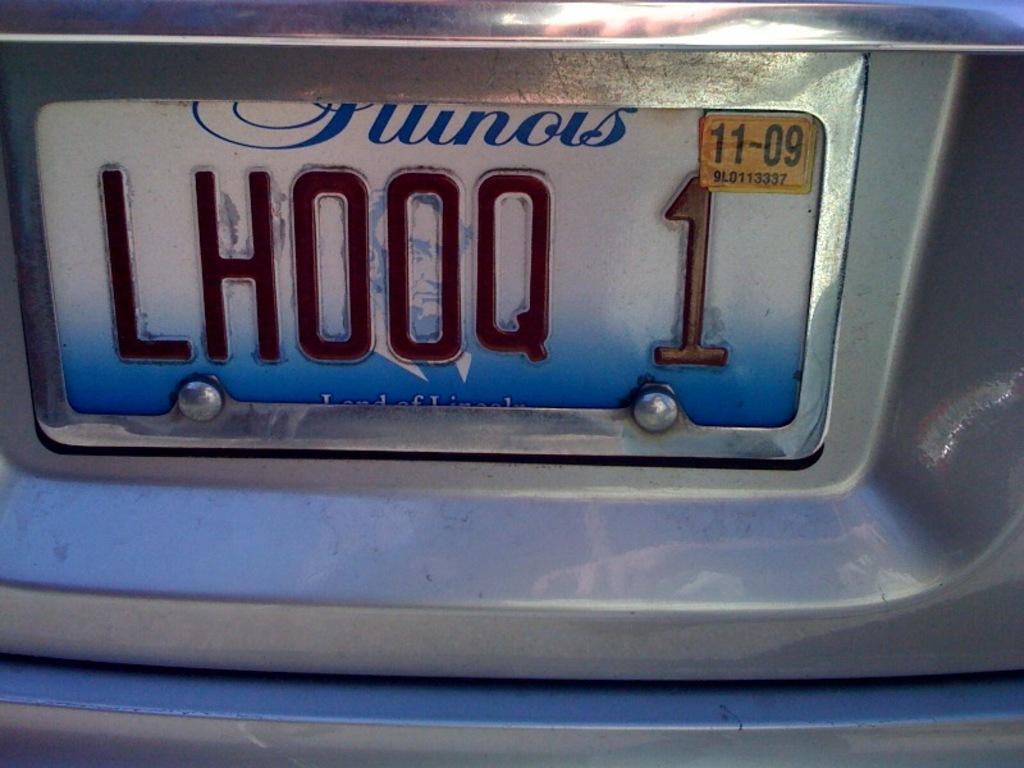What is the month and year on the sticker?
Give a very brief answer. 11-09. 